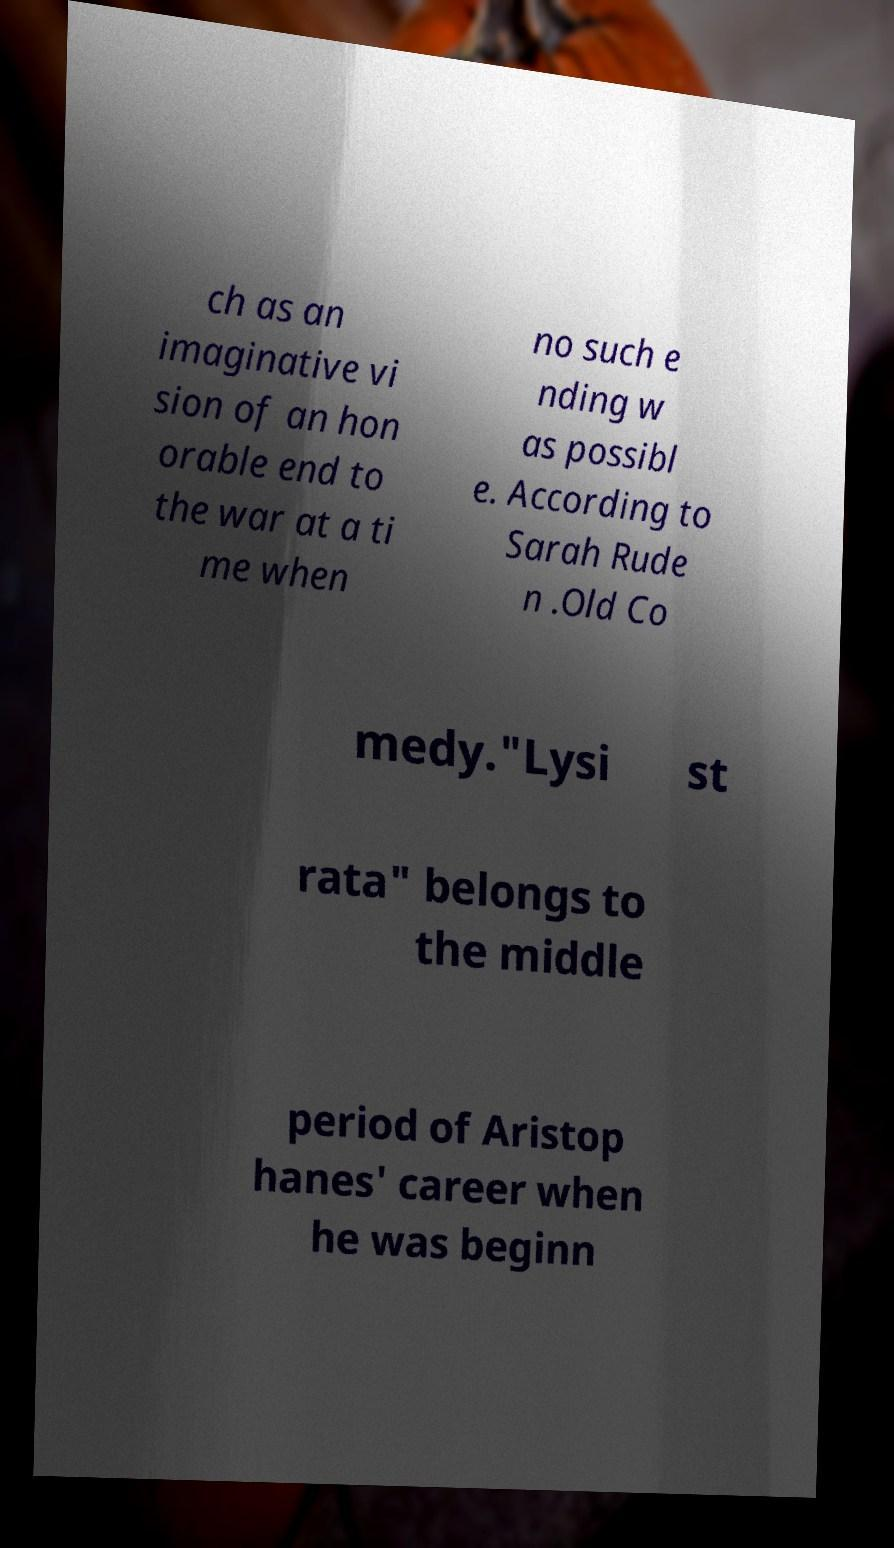Please identify and transcribe the text found in this image. ch as an imaginative vi sion of an hon orable end to the war at a ti me when no such e nding w as possibl e. According to Sarah Rude n .Old Co medy."Lysi st rata" belongs to the middle period of Aristop hanes' career when he was beginn 